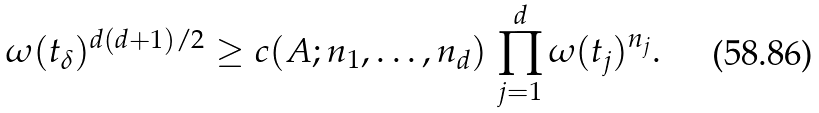Convert formula to latex. <formula><loc_0><loc_0><loc_500><loc_500>\omega ( t _ { \delta } ) ^ { d ( d + 1 ) / 2 } \geq c ( A ; n _ { 1 } , \dots , n _ { d } ) \, \prod _ { j = 1 } ^ { d } \omega ( t _ { j } ) ^ { n _ { j } } .</formula> 